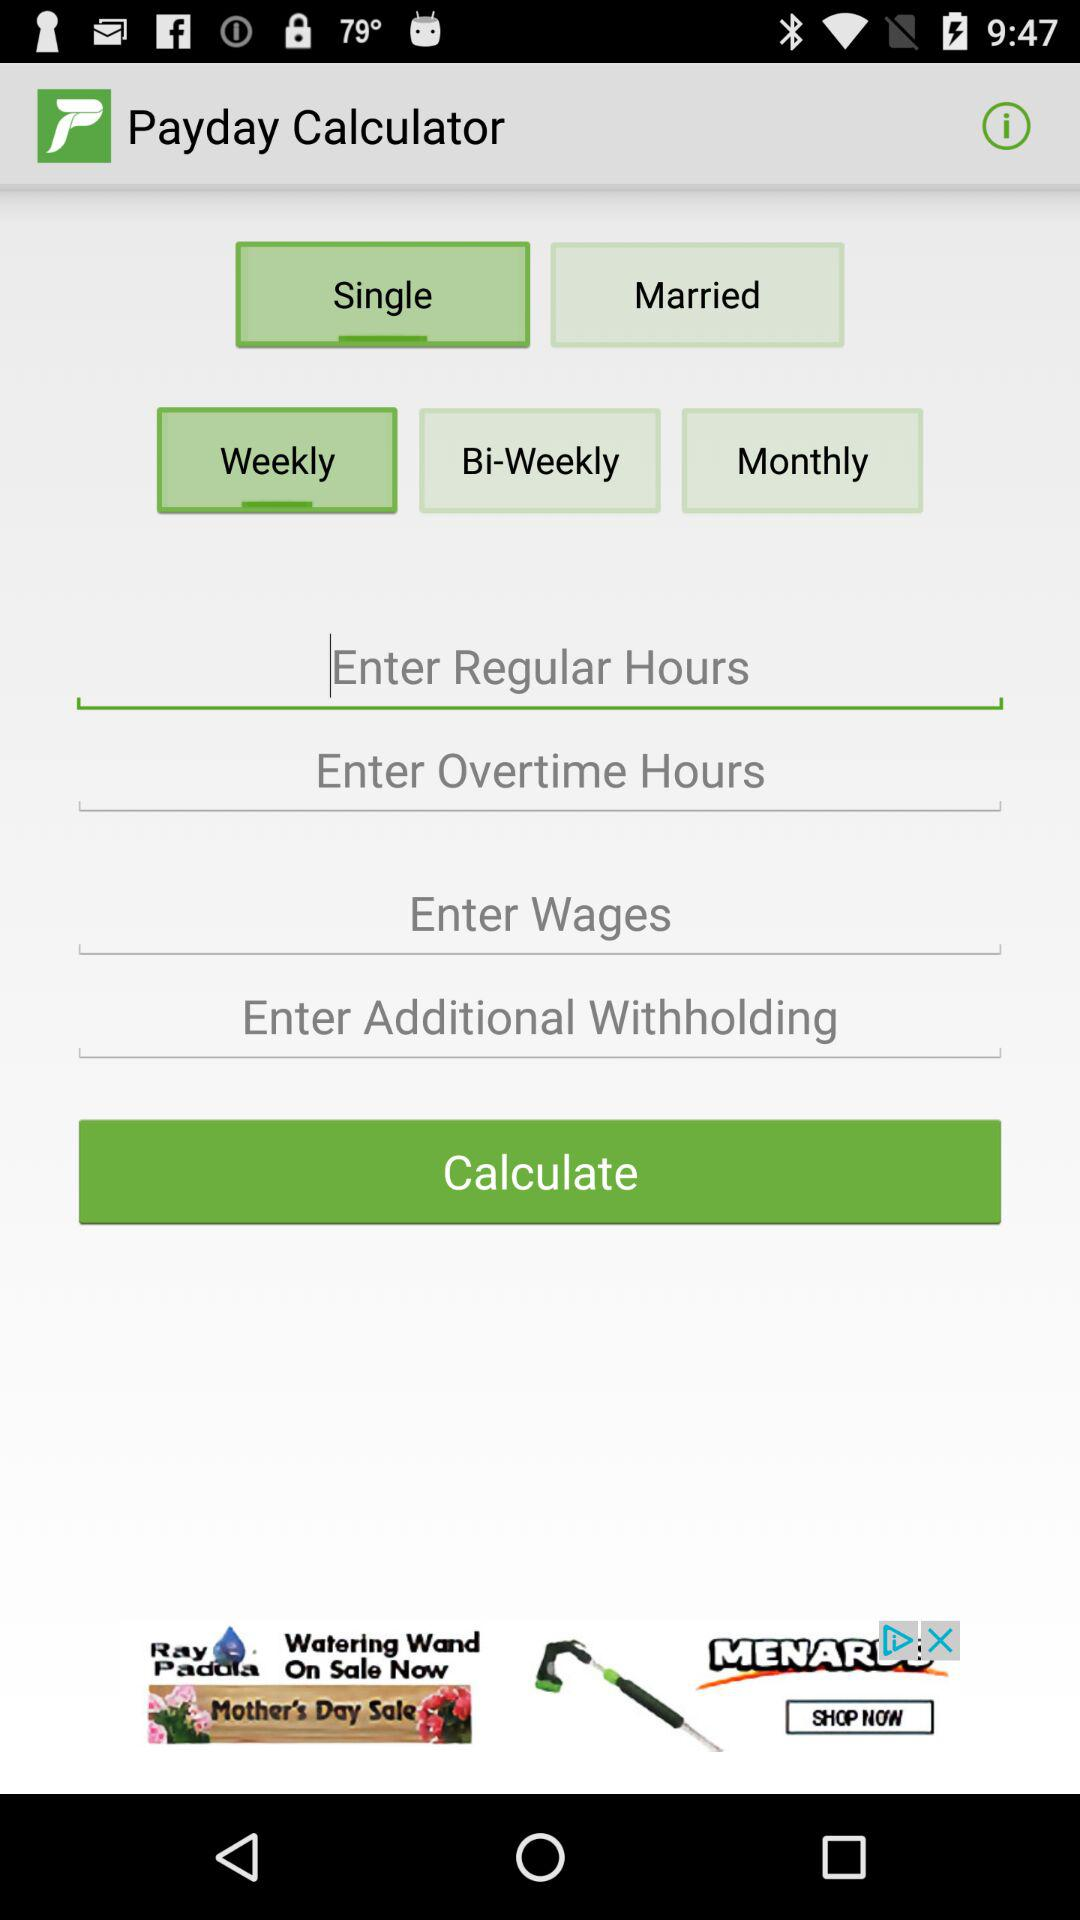When to pay via this application? Pay weekly via this application. 